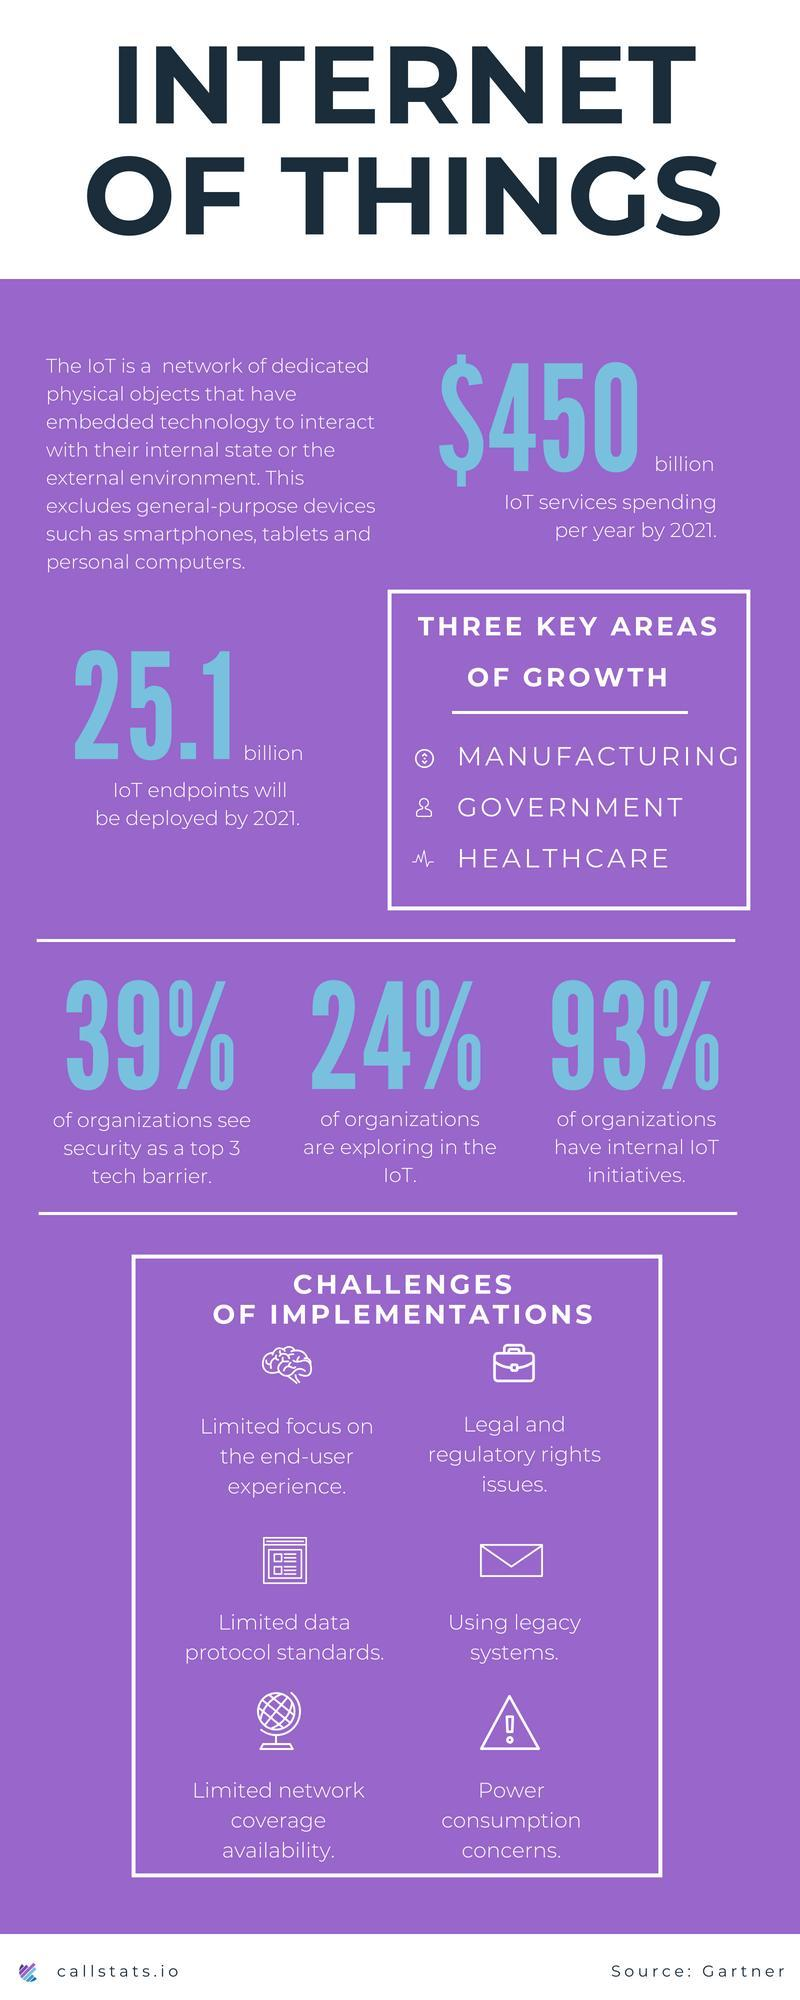What is the key area of growth for IoT other than manufacturing & government?
Answer the question with a short phrase. HEALTHCARE What percentage of organizations have internal IoT initiatives? 93% What is the no of IoT endpoints that will be deployed by 2021? 25.1 billion What percentage of organizations see security as a top 3 tech barrier? 39% What percentage of organizations are exploring in the IoT? 24% 